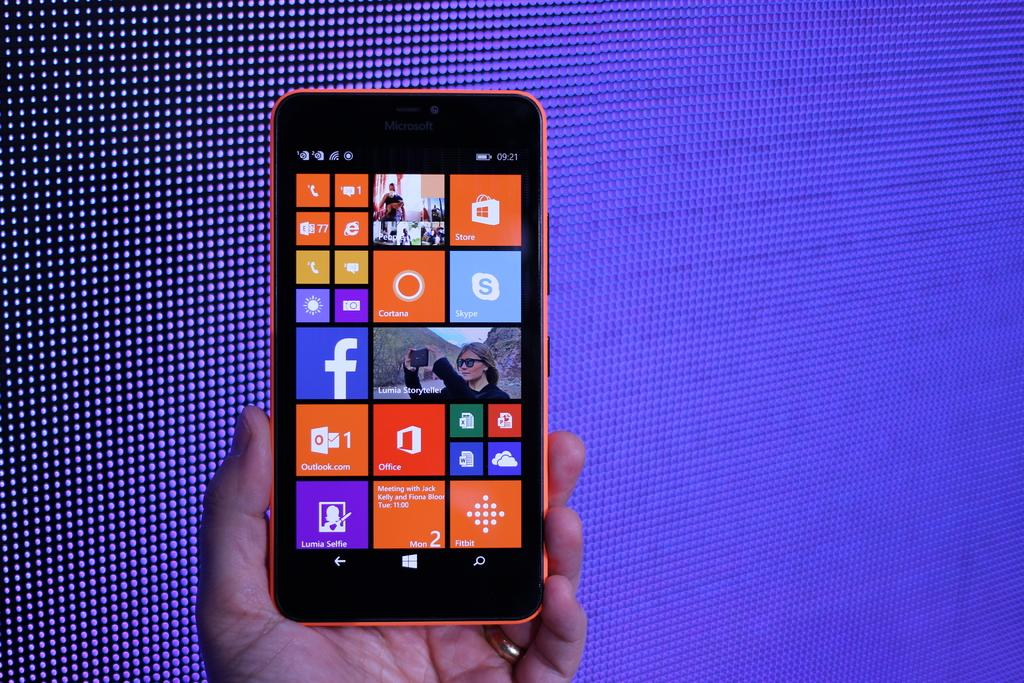Provide a one-sentence caption for the provided image. A hand holding a windows phone with Skype and Facebook apps installed. 